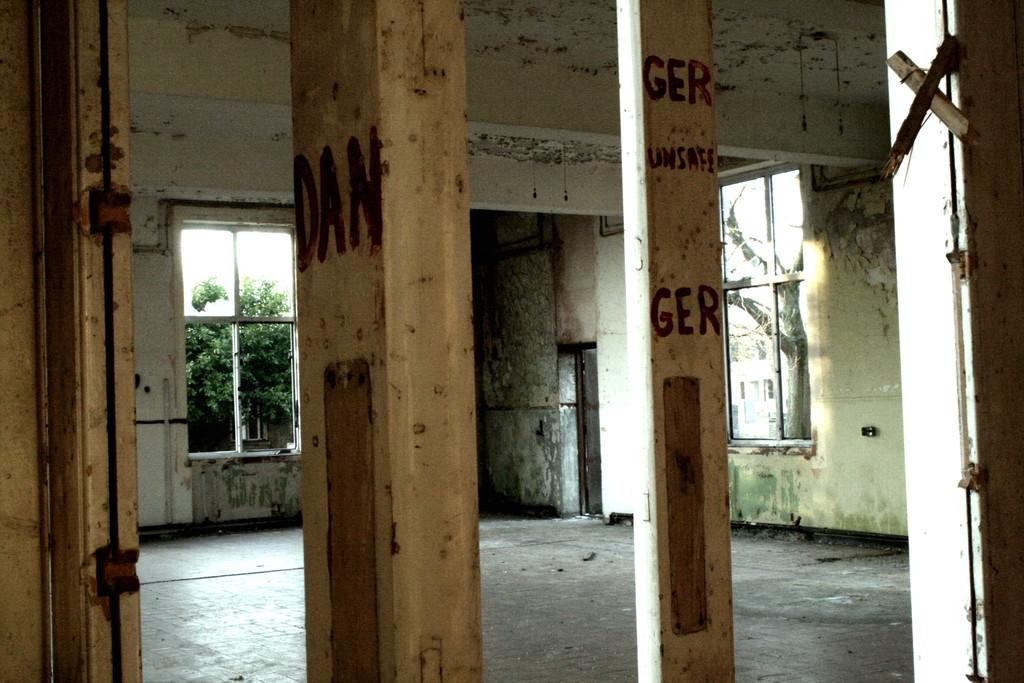What structures are present on the sides of the image? There are two pillars in the image. What can be seen through the openings on either side of the image? There are windows on either side of the image. What type of natural scenery is visible in the background of the image? There are trees in the background of the image. What type of pie is being served on the railway in the image? There is no pie or railway present in the image; it features two pillars and windows with trees in the background. 